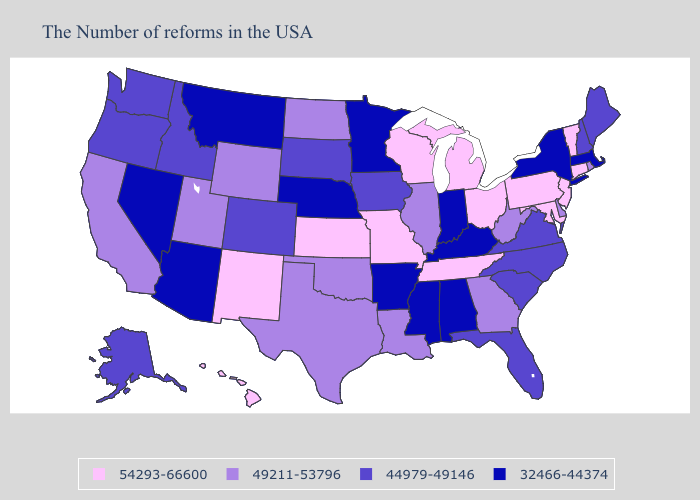Among the states that border Wisconsin , which have the highest value?
Give a very brief answer. Michigan. What is the highest value in the Northeast ?
Keep it brief. 54293-66600. Does Indiana have the same value as Louisiana?
Quick response, please. No. Does the map have missing data?
Short answer required. No. Name the states that have a value in the range 44979-49146?
Keep it brief. Maine, New Hampshire, Virginia, North Carolina, South Carolina, Florida, Iowa, South Dakota, Colorado, Idaho, Washington, Oregon, Alaska. Name the states that have a value in the range 44979-49146?
Short answer required. Maine, New Hampshire, Virginia, North Carolina, South Carolina, Florida, Iowa, South Dakota, Colorado, Idaho, Washington, Oregon, Alaska. What is the highest value in states that border Ohio?
Keep it brief. 54293-66600. Does the map have missing data?
Keep it brief. No. Name the states that have a value in the range 44979-49146?
Write a very short answer. Maine, New Hampshire, Virginia, North Carolina, South Carolina, Florida, Iowa, South Dakota, Colorado, Idaho, Washington, Oregon, Alaska. Name the states that have a value in the range 49211-53796?
Quick response, please. Rhode Island, Delaware, West Virginia, Georgia, Illinois, Louisiana, Oklahoma, Texas, North Dakota, Wyoming, Utah, California. Among the states that border Connecticut , does New York have the highest value?
Quick response, please. No. What is the lowest value in the West?
Be succinct. 32466-44374. Name the states that have a value in the range 32466-44374?
Give a very brief answer. Massachusetts, New York, Kentucky, Indiana, Alabama, Mississippi, Arkansas, Minnesota, Nebraska, Montana, Arizona, Nevada. Name the states that have a value in the range 54293-66600?
Keep it brief. Vermont, Connecticut, New Jersey, Maryland, Pennsylvania, Ohio, Michigan, Tennessee, Wisconsin, Missouri, Kansas, New Mexico, Hawaii. Does Minnesota have the lowest value in the USA?
Short answer required. Yes. 